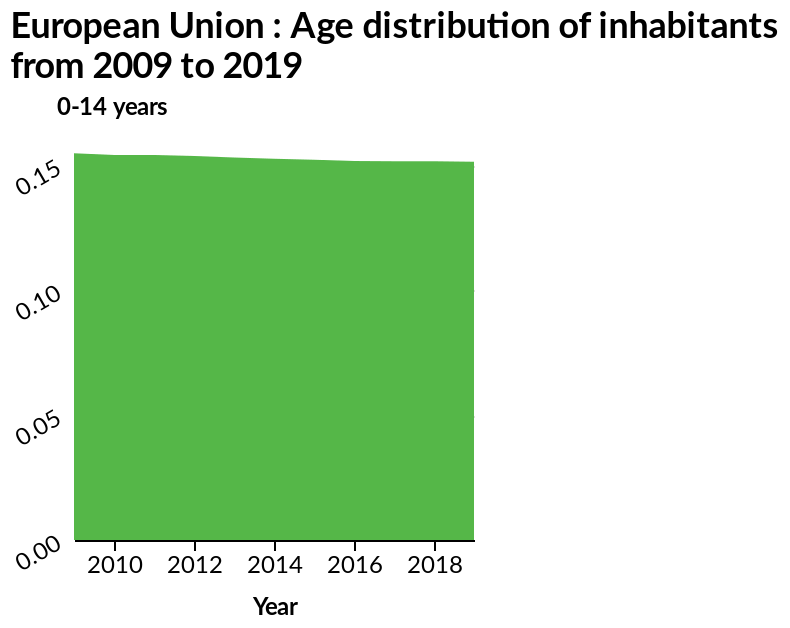<image>
What is the range of the y-axis scale? The y-axis scale ranges from a minimum of 0.00 to a maximum of 0.15. Offer a thorough analysis of the image. The age distribution of the European Union remains pretty constant between 2009-2019. Describe the following image in detail European Union : Age distribution of inhabitants from 2009 to 2019 is a area graph. The x-axis plots Year along linear scale of range 2010 to 2018 while the y-axis measures 0-14 years using scale with a minimum of 0.00 and a maximum of 0.15. Which year had the lowest y-axis value?  2018 had the lowest y-axis value. 